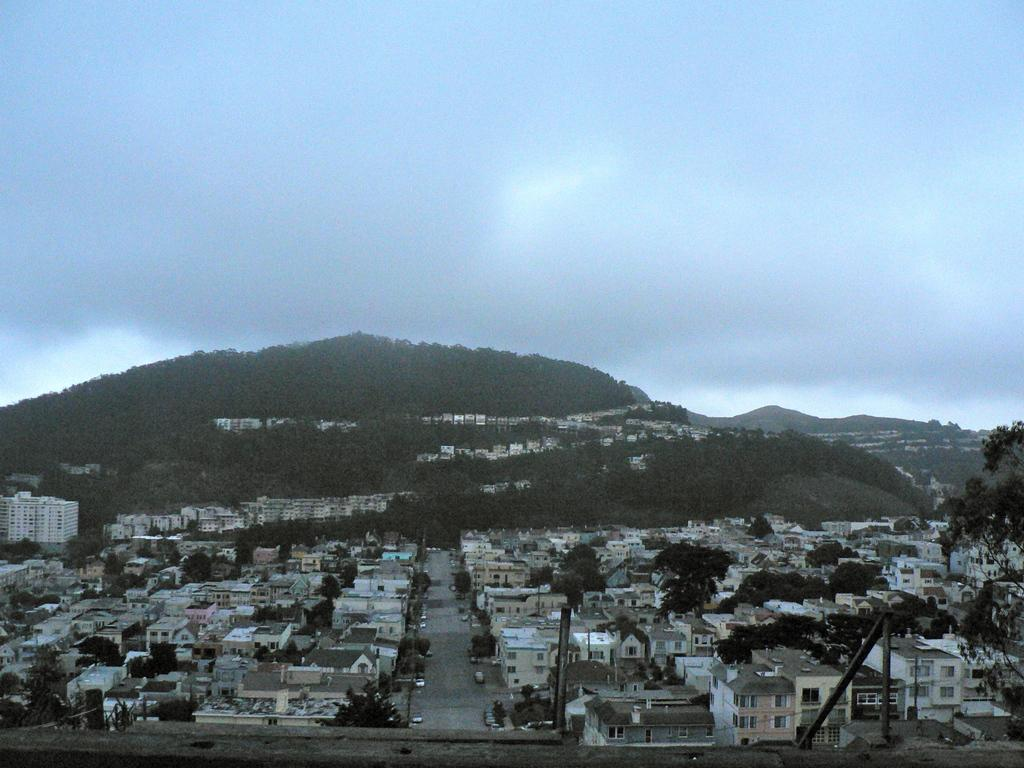What type of structures can be seen in the image? There are many buildings in the image. What other natural elements are present in the image? There are trees in the image. What is happening on the road in the image? There are vehicles on the road in the image. Can you describe the landscape in the image? There are hills with trees in the image. What type of stamp can be seen on the buildings in the image? There is no stamp present on the buildings in the image. What is the source of the flame visible in the image? There is no flame present in the image. 